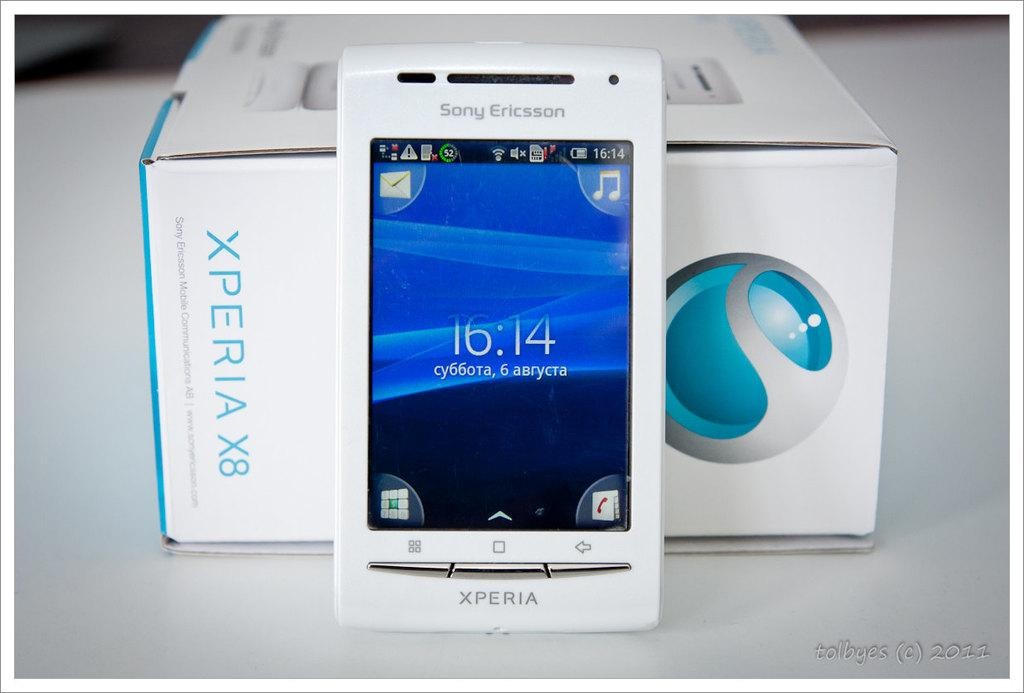<image>
Provide a brief description of the given image. A white Xperia phone shows that the time in 16:14 and has its box behind it. 